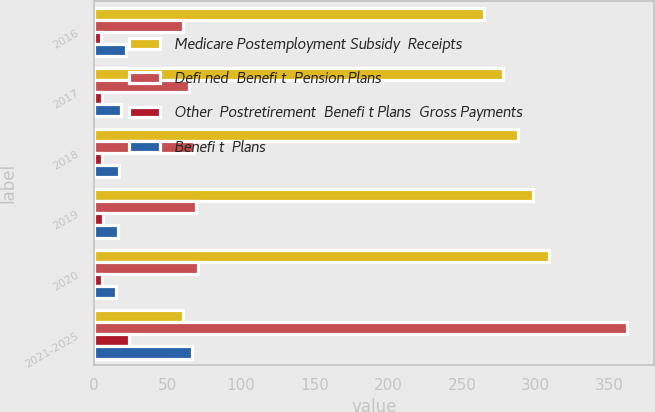Convert chart to OTSL. <chart><loc_0><loc_0><loc_500><loc_500><stacked_bar_chart><ecel><fcel>2016<fcel>2017<fcel>2018<fcel>2019<fcel>2020<fcel>2021-2025<nl><fcel>Medicare Postemployment Subsidy  Receipts<fcel>264.7<fcel>278.1<fcel>288.3<fcel>298.6<fcel>309.3<fcel>60.8<nl><fcel>Defi ned  Benefi t  Pension Plans<fcel>60.8<fcel>64.8<fcel>67.7<fcel>69.6<fcel>70.8<fcel>362.3<nl><fcel>Other  Postretirement  Benefi t Plans  Gross Payments<fcel>4.8<fcel>5.2<fcel>5.6<fcel>6<fcel>5.5<fcel>23.6<nl><fcel>Benefi t  Plans<fcel>21.9<fcel>18.5<fcel>17.3<fcel>16.1<fcel>15.2<fcel>66.7<nl></chart> 